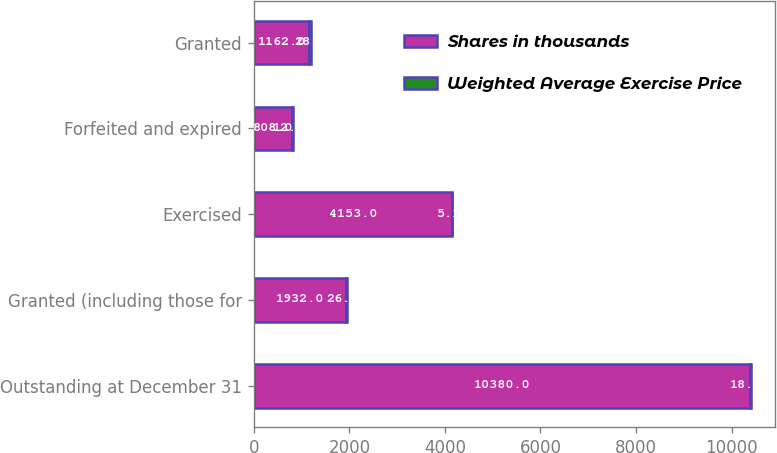<chart> <loc_0><loc_0><loc_500><loc_500><stacked_bar_chart><ecel><fcel>Outstanding at December 31<fcel>Granted (including those for<fcel>Exercised<fcel>Forfeited and expired<fcel>Granted<nl><fcel>Shares in thousands<fcel>10380<fcel>1932<fcel>4153<fcel>808<fcel>1162<nl><fcel>Weighted Average Exercise Price<fcel>18.76<fcel>26.96<fcel>5.18<fcel>12.19<fcel>28.2<nl></chart> 